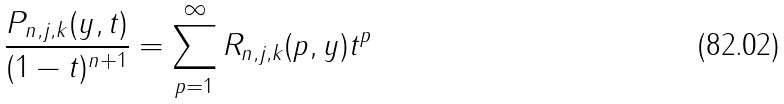<formula> <loc_0><loc_0><loc_500><loc_500>\frac { P _ { n , j , k } ( y , t ) } { ( 1 - t ) ^ { n + 1 } } = \sum _ { p = 1 } ^ { \infty } R _ { n , j , k } ( p , y ) t ^ { p }</formula> 